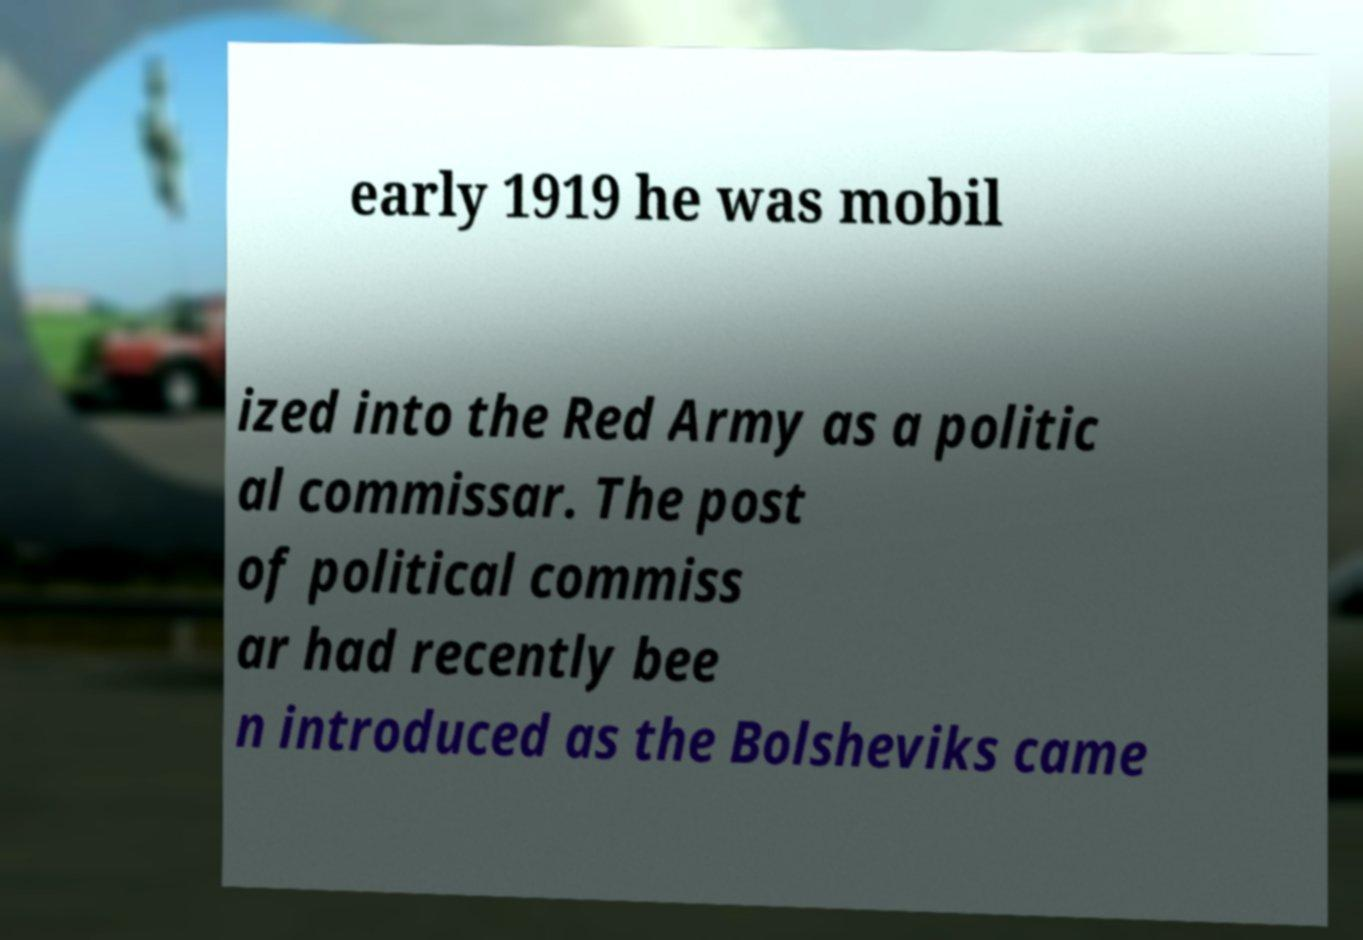Could you assist in decoding the text presented in this image and type it out clearly? early 1919 he was mobil ized into the Red Army as a politic al commissar. The post of political commiss ar had recently bee n introduced as the Bolsheviks came 